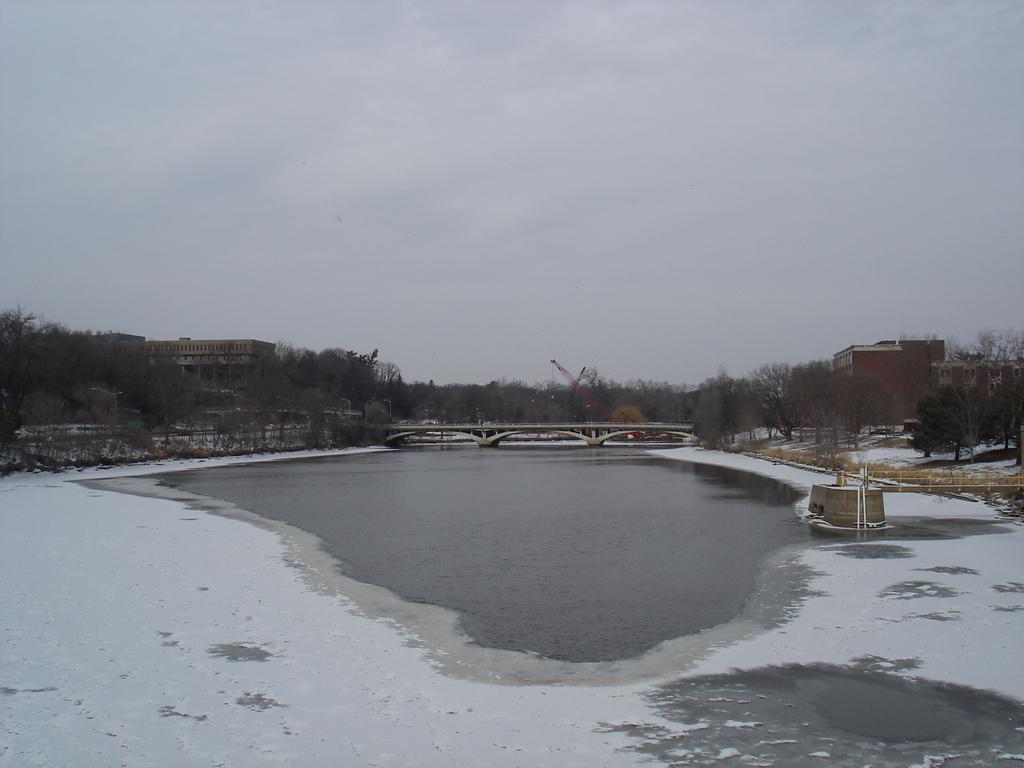What is the primary element in the image? There is water in the image. What is covering the water in the image? There is snow on the water. What can be seen in the background of the image? There is a bridge built on the water, trees, buildings, and clouds in the sky. What type of receipt can be seen on the canvas in the image? There is no canvas or receipt present in the image. 